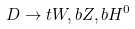<formula> <loc_0><loc_0><loc_500><loc_500>D \to t W , b Z , b H ^ { 0 }</formula> 